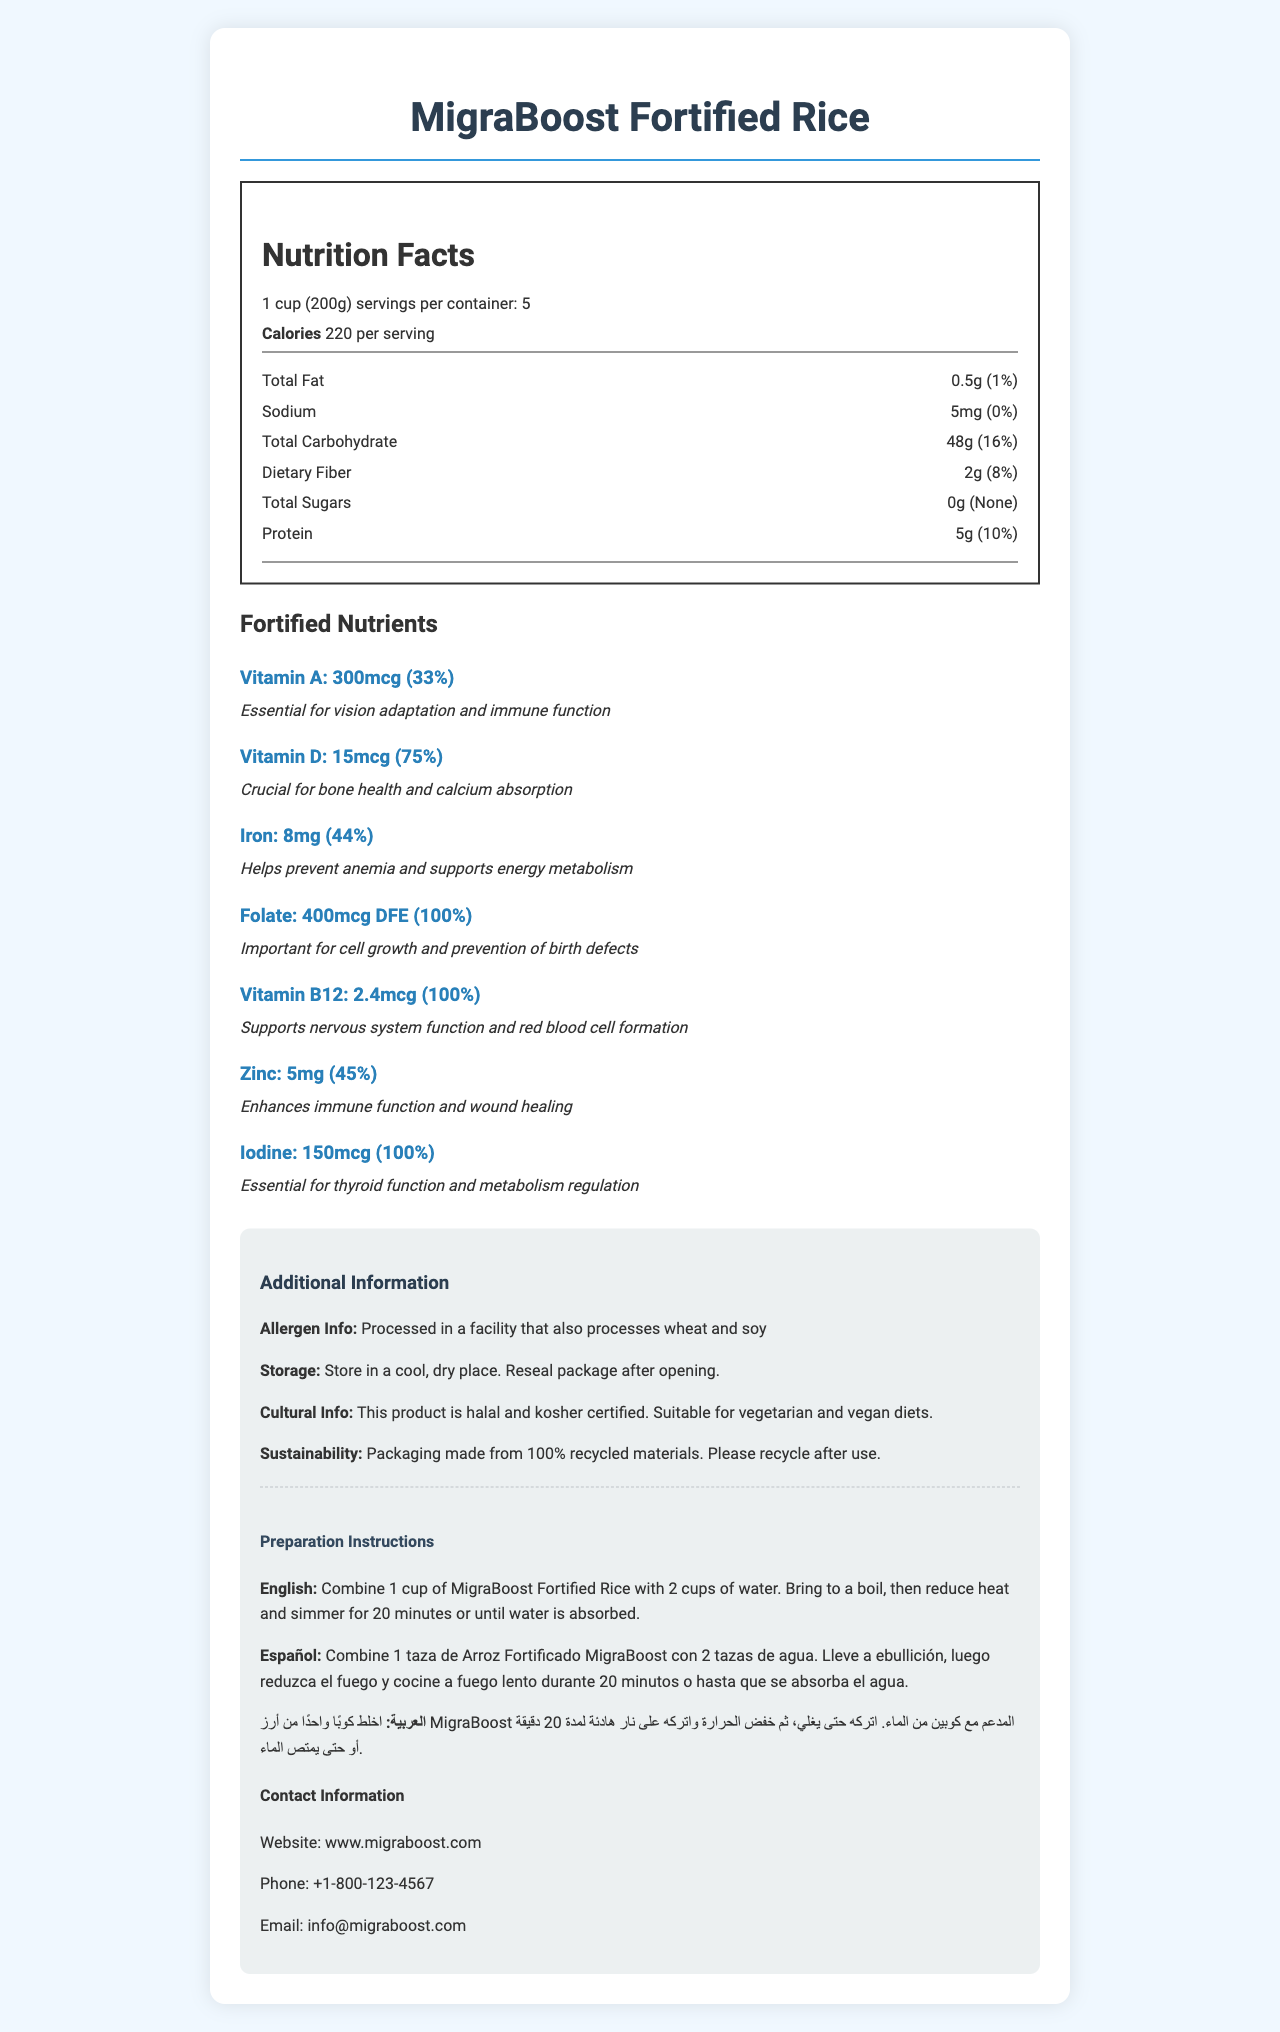what is the name of the product? The name of the product is clearly listed at the top of the document.
Answer: MigraBoost Fortified Rice what is the serving size for MigraBoost Fortified Rice? The document specifies the serving size as "1 cup (200g)".
Answer: 1 cup (200g) how many servings are there per container? The document states that there are 5 servings per container.
Answer: 5 how many calories are there per serving? The document shows that there are 220 calories per serving.
Answer: 220 how many grams of protein does each serving contain? The nutrition facts section lists 5g of protein per serving.
Answer: 5g what is the recommended daily value percentage of Vitamin A per serving? The fortified nutrients section lists Vitamin A with a daily value of 33%.
Answer: 33% why is Iron included in MigraBoost Fortified Rice? The document explains that Iron helps prevent anemia and supports energy metabolism.
Answer: Helps prevent anemia and supports energy metabolism which of the following nutrients has the highest daily value percentage per serving? A. Vitamin A B. Iron C. Vitamin D D. Vitamin B12 The nutrition facts show that Vitamin B12 and Folate each have a daily value of 100%, but Vitamin B12 is explicitly mentioned in the question.
Answer: D. Vitamin B12 which of the following nutrients is crucial for bone health and calcium absorption? A. Vitamin A B. Folate C. Vitamin D D. Zinc The fortified nutrients section explains that Vitamin D is crucial for bone health and calcium absorption.
Answer: C. Vitamin D is this product suitable for vegan diets? The cultural information indicates that the product is suitable for vegetarian and vegan diets.
Answer: Yes does MigraBoost Fortified Rice contain any added sugars? The nutrition facts section lists "Total Sugars" as 0g.
Answer: No summarize the main features of MigraBoost Fortified Rice. The document provides detailed information about the nutritional content, added nutrients, allergen information, storage and preparation instructions, cultural compatibility, and sustainability of MigraBoost Fortified Rice.
Answer: MigraBoost Fortified Rice is a fortified rice product designed to address common nutritional deficiencies among migrants. It provides essential vitamins and minerals such as Vitamin A, Vitamin D, Iron, Folate, Vitamin B12, Zinc, and Iodine. The product is halal and kosher certified, suitable for vegetarian and vegan diets, and has detailed preparation instructions in multiple languages. It is processed in a facility that also handles wheat and soy and comes in packaging made from 100% recycled materials. how many calories are in a whole container of MigraBoost Fortified Rice? The document provides the calorie count per serving but does not directly state the total calories in the whole container.
Answer: Not enough information what is the amount of dietary fiber per serving and its daily value percentage? The nutrition facts list dietary fiber as 2g per serving, with a daily value of 8%.
Answer: 2g, 8% what facilities is this product processed in? The additional information section mentions that the product is processed in a facility that also processes wheat and soy.
Answer: Processed in a facility that also processes wheat and soy where can you find more information about MigraBoost Fortified Rice? The contact information section provides the website, phone number, and email for more information.
Answer: Website: www.migraboost.com, Phone: +1-800-123-4567, Email: info@migraboost.com 